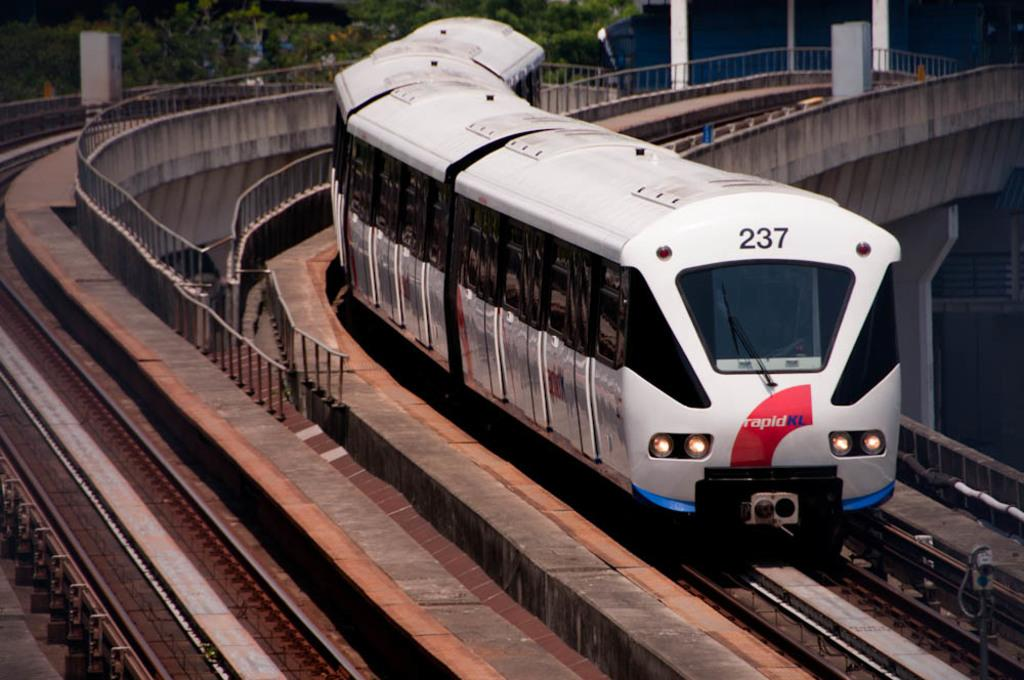<image>
Provide a brief description of the given image. A rapidKL train with number 237 on it is driving on train tracks. 